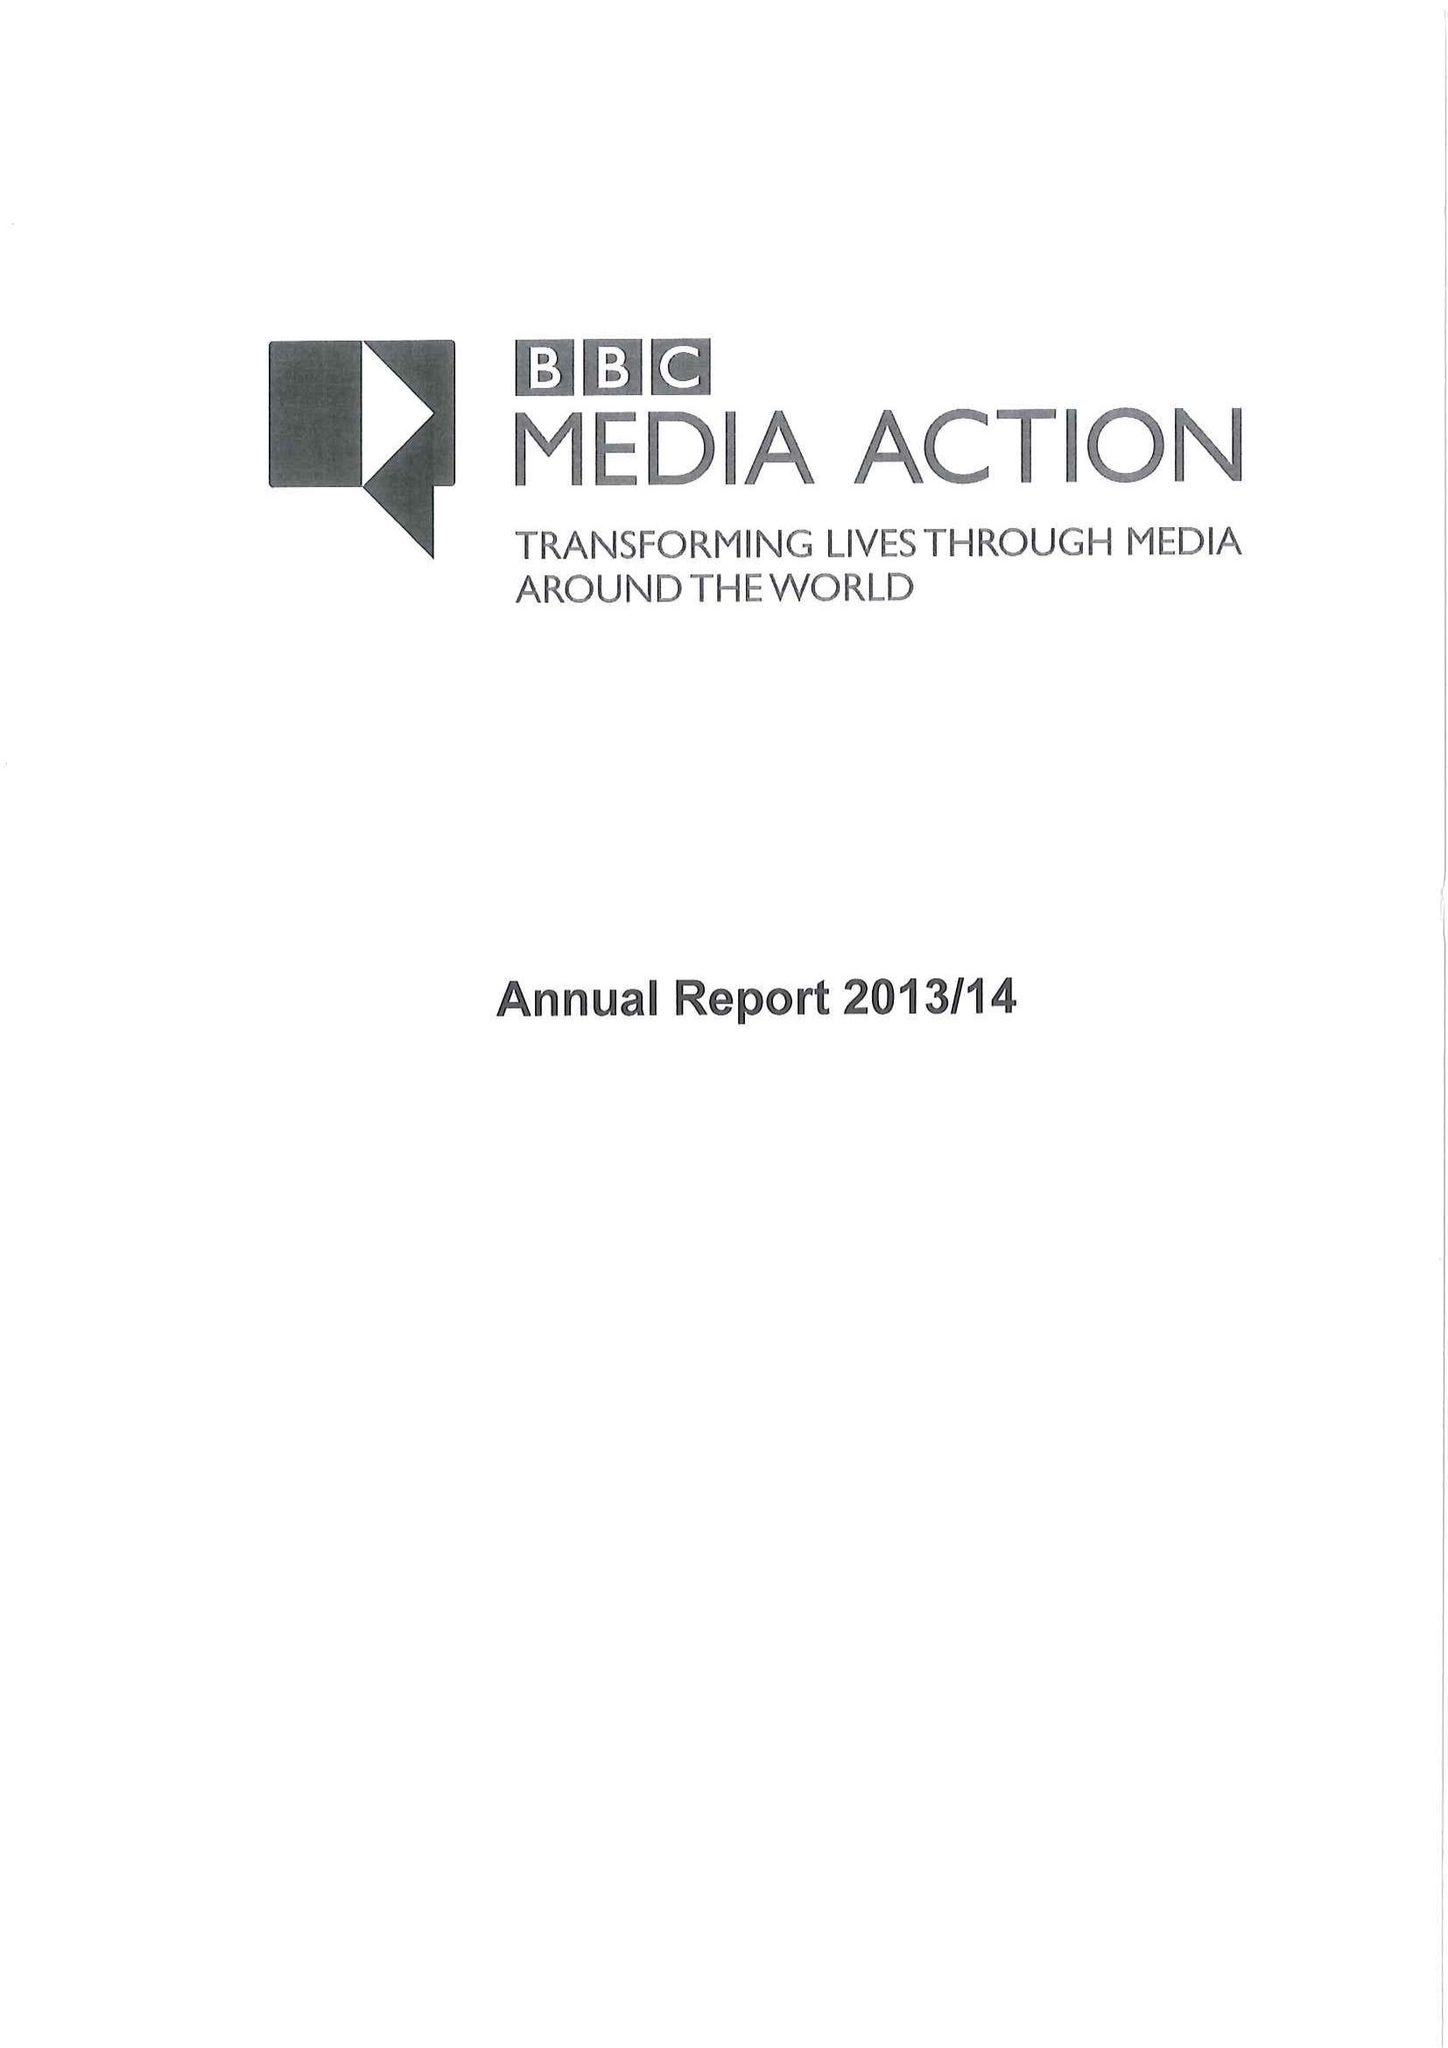What is the value for the charity_number?
Answer the question using a single word or phrase. 1076235 